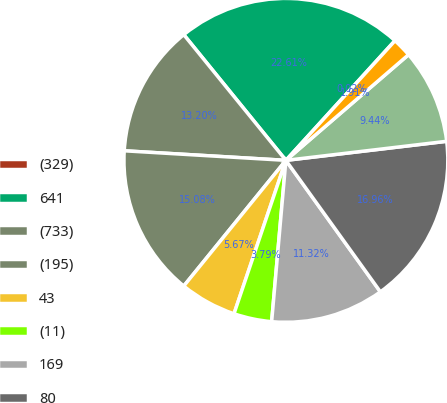Convert chart. <chart><loc_0><loc_0><loc_500><loc_500><pie_chart><fcel>(329)<fcel>641<fcel>(733)<fcel>(195)<fcel>43<fcel>(11)<fcel>169<fcel>80<fcel>(10)<fcel>70<nl><fcel>0.02%<fcel>22.61%<fcel>13.2%<fcel>15.08%<fcel>5.67%<fcel>3.79%<fcel>11.32%<fcel>16.96%<fcel>9.44%<fcel>1.91%<nl></chart> 